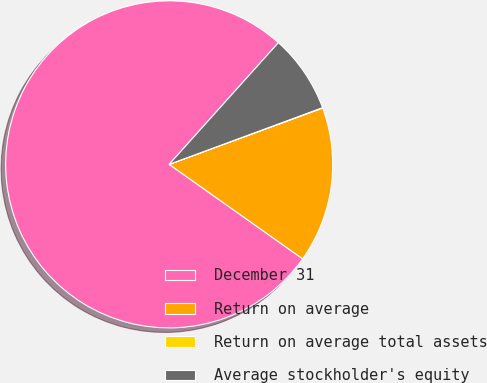Convert chart to OTSL. <chart><loc_0><loc_0><loc_500><loc_500><pie_chart><fcel>December 31<fcel>Return on average<fcel>Return on average total assets<fcel>Average stockholder's equity<nl><fcel>76.84%<fcel>15.4%<fcel>0.04%<fcel>7.72%<nl></chart> 